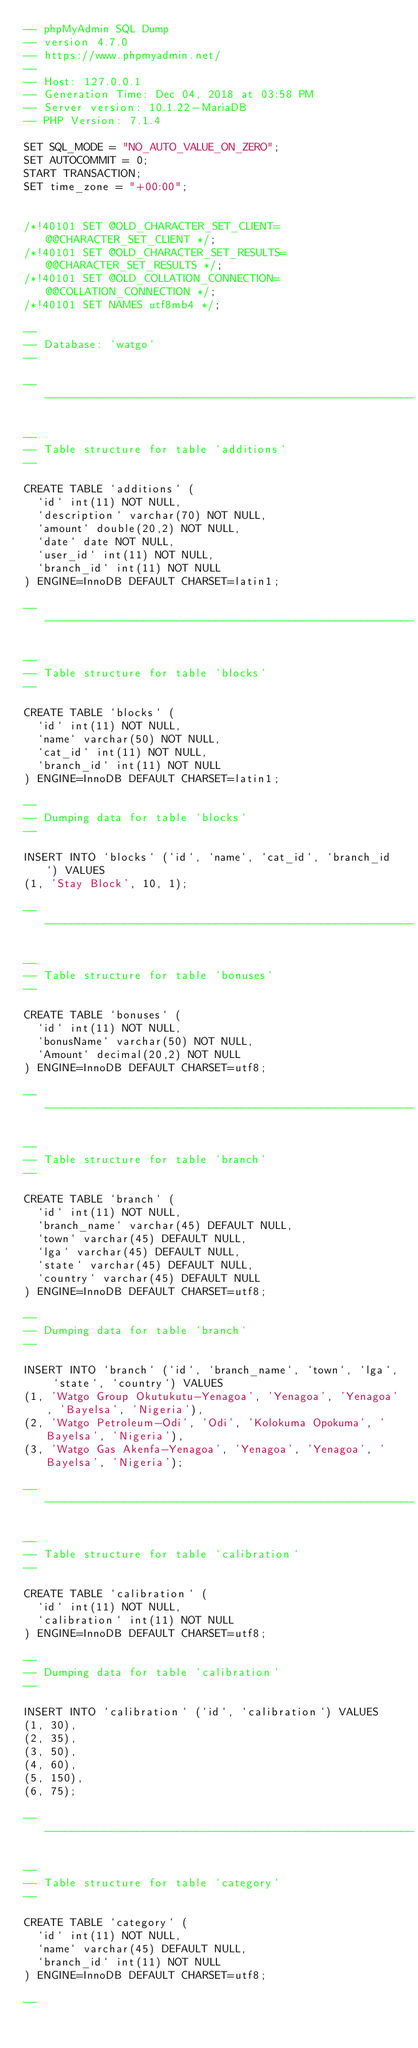<code> <loc_0><loc_0><loc_500><loc_500><_SQL_>-- phpMyAdmin SQL Dump
-- version 4.7.0
-- https://www.phpmyadmin.net/
--
-- Host: 127.0.0.1
-- Generation Time: Dec 04, 2018 at 03:58 PM
-- Server version: 10.1.22-MariaDB
-- PHP Version: 7.1.4

SET SQL_MODE = "NO_AUTO_VALUE_ON_ZERO";
SET AUTOCOMMIT = 0;
START TRANSACTION;
SET time_zone = "+00:00";


/*!40101 SET @OLD_CHARACTER_SET_CLIENT=@@CHARACTER_SET_CLIENT */;
/*!40101 SET @OLD_CHARACTER_SET_RESULTS=@@CHARACTER_SET_RESULTS */;
/*!40101 SET @OLD_COLLATION_CONNECTION=@@COLLATION_CONNECTION */;
/*!40101 SET NAMES utf8mb4 */;

--
-- Database: `watgo`
--

-- --------------------------------------------------------

--
-- Table structure for table `additions`
--

CREATE TABLE `additions` (
  `id` int(11) NOT NULL,
  `description` varchar(70) NOT NULL,
  `amount` double(20,2) NOT NULL,
  `date` date NOT NULL,
  `user_id` int(11) NOT NULL,
  `branch_id` int(11) NOT NULL
) ENGINE=InnoDB DEFAULT CHARSET=latin1;

-- --------------------------------------------------------

--
-- Table structure for table `blocks`
--

CREATE TABLE `blocks` (
  `id` int(11) NOT NULL,
  `name` varchar(50) NOT NULL,
  `cat_id` int(11) NOT NULL,
  `branch_id` int(11) NOT NULL
) ENGINE=InnoDB DEFAULT CHARSET=latin1;

--
-- Dumping data for table `blocks`
--

INSERT INTO `blocks` (`id`, `name`, `cat_id`, `branch_id`) VALUES
(1, 'Stay Block', 10, 1);

-- --------------------------------------------------------

--
-- Table structure for table `bonuses`
--

CREATE TABLE `bonuses` (
  `id` int(11) NOT NULL,
  `bonusName` varchar(50) NOT NULL,
  `Amount` decimal(20,2) NOT NULL
) ENGINE=InnoDB DEFAULT CHARSET=utf8;

-- --------------------------------------------------------

--
-- Table structure for table `branch`
--

CREATE TABLE `branch` (
  `id` int(11) NOT NULL,
  `branch_name` varchar(45) DEFAULT NULL,
  `town` varchar(45) DEFAULT NULL,
  `lga` varchar(45) DEFAULT NULL,
  `state` varchar(45) DEFAULT NULL,
  `country` varchar(45) DEFAULT NULL
) ENGINE=InnoDB DEFAULT CHARSET=utf8;

--
-- Dumping data for table `branch`
--

INSERT INTO `branch` (`id`, `branch_name`, `town`, `lga`, `state`, `country`) VALUES
(1, 'Watgo Group Okutukutu-Yenagoa', 'Yenagoa', 'Yenagoa', 'Bayelsa', 'Nigeria'),
(2, 'Watgo Petroleum-Odi', 'Odi', 'Kolokuma Opokuma', 'Bayelsa', 'Nigeria'),
(3, 'Watgo Gas Akenfa-Yenagoa', 'Yenagoa', 'Yenagoa', 'Bayelsa', 'Nigeria');

-- --------------------------------------------------------

--
-- Table structure for table `calibration`
--

CREATE TABLE `calibration` (
  `id` int(11) NOT NULL,
  `calibration` int(11) NOT NULL
) ENGINE=InnoDB DEFAULT CHARSET=utf8;

--
-- Dumping data for table `calibration`
--

INSERT INTO `calibration` (`id`, `calibration`) VALUES
(1, 30),
(2, 35),
(3, 50),
(4, 60),
(5, 150),
(6, 75);

-- --------------------------------------------------------

--
-- Table structure for table `category`
--

CREATE TABLE `category` (
  `id` int(11) NOT NULL,
  `name` varchar(45) DEFAULT NULL,
  `branch_id` int(11) NOT NULL
) ENGINE=InnoDB DEFAULT CHARSET=utf8;

--</code> 